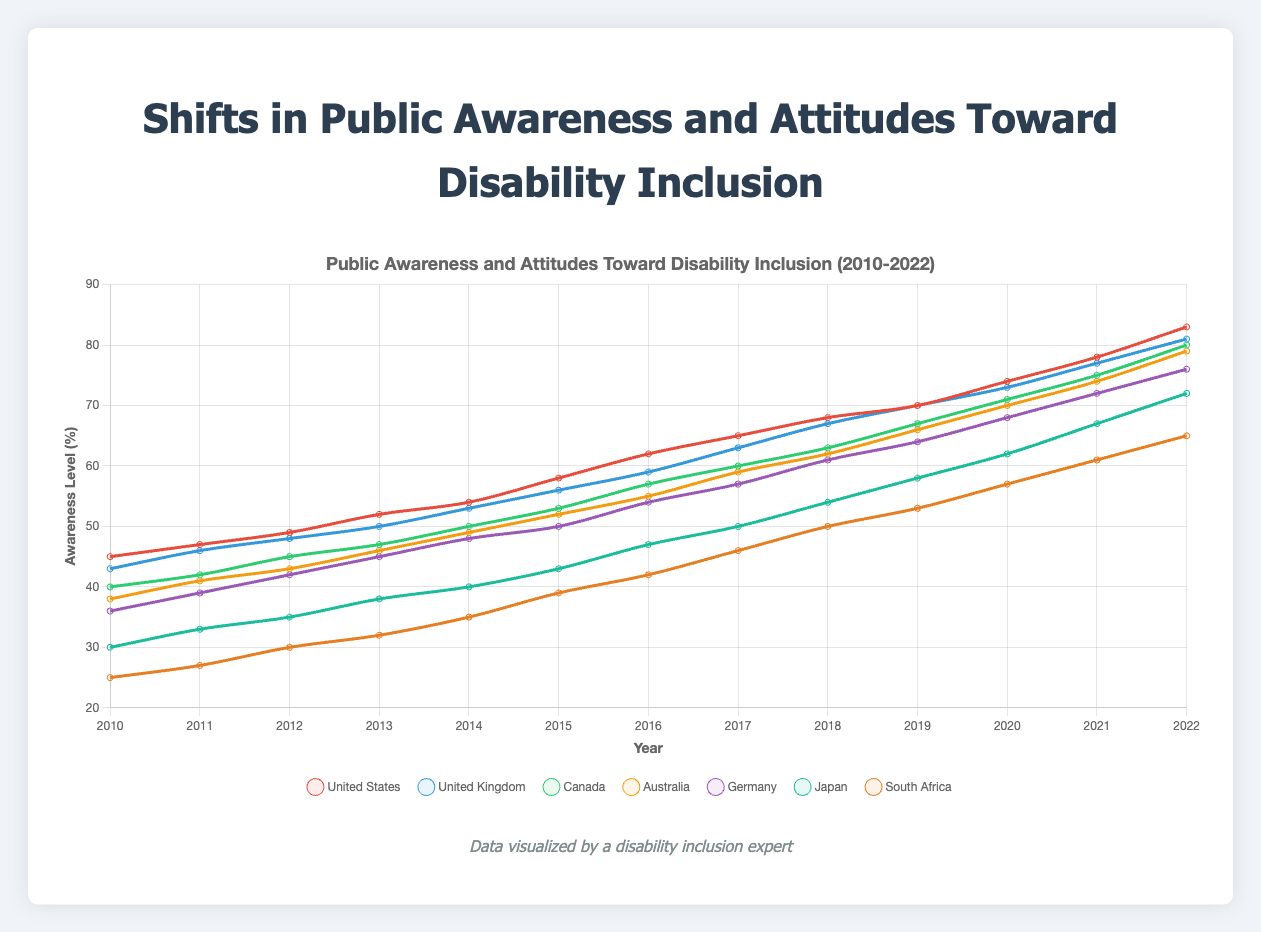What was the level of public awareness in Japan in 2015? To find the level of public awareness in Japan in 2015, locate Japan's line on the chart and find the data point for the year 2015. The chart shows that the value is 43%.
Answer: 43% Which country had the lowest level of public awareness in 2010? To identify the country with the lowest level of public awareness in 2010, compare the data points for all countries in that year. South Africa has the lowest value at 25%.
Answer: South Africa Between 2017 and 2022, which country saw the largest increase in public awareness levels? Calculate the difference in public awareness levels for each country between 2017 and 2022. The increases are as follows: United States (+18), United Kingdom (+18), Canada (+20), Australia (+20), Germany (+19), Japan (+22), South Africa (+19). Japan had the largest increase of 22%.
Answer: Japan Which country had the highest awareness level in 2022? Locate the data points for all countries in 2022 and identify the highest one. The United States had the highest awareness level at 83%.
Answer: United States How did the public awareness level in Australia change from 2012 to 2018? Find the values for Australia in 2012 and 2018. In 2012, it was 43%, and in 2018, it was 62%. Subtract the earlier value from the later one: 62 - 43 = 19. The public awareness level increased by 19%.
Answer: Increased by 19% Compare the public awareness levels of Germany and Canada in 2020. Which was higher and by how much? First, find the values for Germany and Canada in 2020. Germany had 68%, and Canada had 71%. The difference is 71 - 68 = 3. Canada's level was higher by 3%.
Answer: Canada was higher by 3% What is the average public awareness level for the United Kingdom across the whole period (2010-2022)? Add all the yearly values for the United Kingdom from 2010 to 2022 and divide by the number of years. (43 + 46 + 48 + 50 + 53 + 56 + 59 + 63 + 67 + 70 + 73 + 77 + 81) / 13 = 60.62. The average level is approximately 60.62%.
Answer: 60.62% Which two countries had the most similar public awareness levels in 2014, and what were those levels? Find the 2014 data points for all countries and compare them. United Kingdom had 53%, and Australia had 49%, which are the closest values.
Answer: United Kingdom (53%) and Australia (49%) By how many percentage points did the public awareness level in South Africa increase from 2015 to 2022? Subtract the 2015 value (39%) from the 2022 value (65%). The increase is 65 - 39 = 26. The awareness level in South Africa increased by 26 percentage points.
Answer: 26 What was the general trend of public awareness levels across all countries from 2010 to 2022? Observe the trend lines for each country from 2010 to 2022. All lines show an upward trend, indicating that public awareness levels increased over this period.
Answer: Increasing 